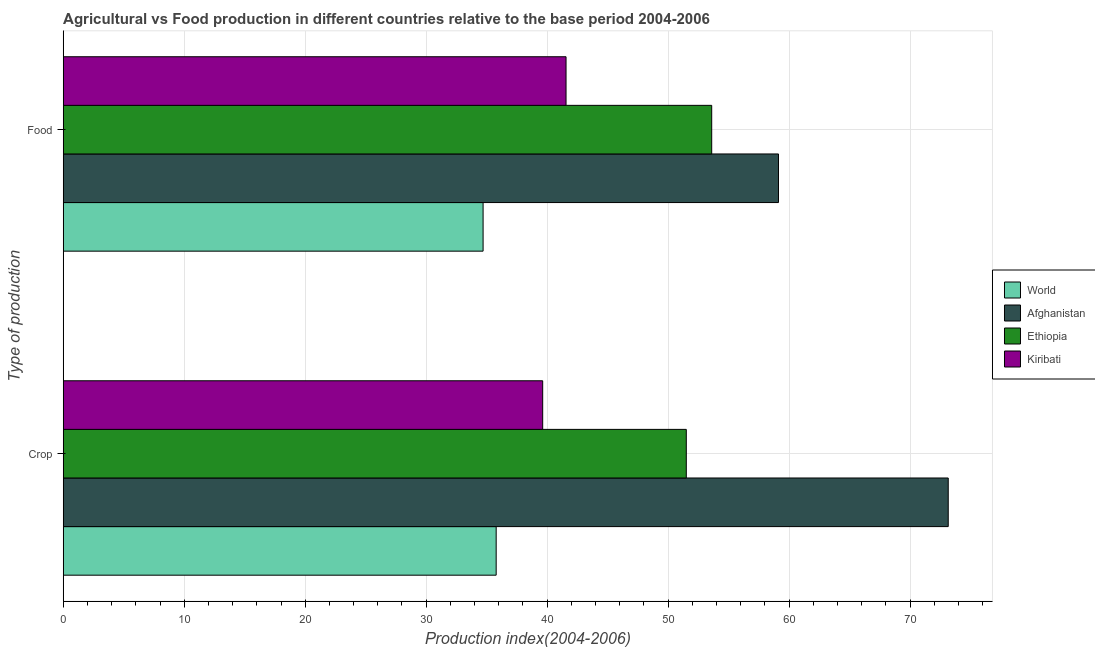How many different coloured bars are there?
Ensure brevity in your answer.  4. Are the number of bars per tick equal to the number of legend labels?
Your response must be concise. Yes. Are the number of bars on each tick of the Y-axis equal?
Your answer should be very brief. Yes. What is the label of the 1st group of bars from the top?
Offer a terse response. Food. What is the crop production index in Ethiopia?
Provide a short and direct response. 51.5. Across all countries, what is the maximum crop production index?
Your answer should be very brief. 73.15. Across all countries, what is the minimum crop production index?
Provide a succinct answer. 35.78. In which country was the food production index maximum?
Keep it short and to the point. Afghanistan. What is the total crop production index in the graph?
Your answer should be very brief. 200.06. What is the difference between the food production index in Afghanistan and that in Kiribati?
Your response must be concise. 17.56. What is the difference between the food production index in World and the crop production index in Kiribati?
Ensure brevity in your answer.  -4.93. What is the average crop production index per country?
Offer a terse response. 50.02. What is the difference between the crop production index and food production index in World?
Your answer should be compact. 1.08. In how many countries, is the food production index greater than 38 ?
Your response must be concise. 3. What is the ratio of the crop production index in Ethiopia to that in Kiribati?
Ensure brevity in your answer.  1.3. In how many countries, is the food production index greater than the average food production index taken over all countries?
Make the answer very short. 2. What does the 3rd bar from the top in Food represents?
Your response must be concise. Afghanistan. How many bars are there?
Your answer should be compact. 8. Does the graph contain any zero values?
Provide a succinct answer. No. Where does the legend appear in the graph?
Your response must be concise. Center right. How many legend labels are there?
Offer a terse response. 4. How are the legend labels stacked?
Give a very brief answer. Vertical. What is the title of the graph?
Provide a succinct answer. Agricultural vs Food production in different countries relative to the base period 2004-2006. Does "Canada" appear as one of the legend labels in the graph?
Offer a terse response. No. What is the label or title of the X-axis?
Provide a succinct answer. Production index(2004-2006). What is the label or title of the Y-axis?
Offer a very short reply. Type of production. What is the Production index(2004-2006) of World in Crop?
Ensure brevity in your answer.  35.78. What is the Production index(2004-2006) in Afghanistan in Crop?
Give a very brief answer. 73.15. What is the Production index(2004-2006) in Ethiopia in Crop?
Ensure brevity in your answer.  51.5. What is the Production index(2004-2006) in Kiribati in Crop?
Offer a very short reply. 39.63. What is the Production index(2004-2006) in World in Food?
Give a very brief answer. 34.7. What is the Production index(2004-2006) of Afghanistan in Food?
Ensure brevity in your answer.  59.12. What is the Production index(2004-2006) of Ethiopia in Food?
Ensure brevity in your answer.  53.6. What is the Production index(2004-2006) in Kiribati in Food?
Provide a succinct answer. 41.56. Across all Type of production, what is the maximum Production index(2004-2006) in World?
Offer a very short reply. 35.78. Across all Type of production, what is the maximum Production index(2004-2006) of Afghanistan?
Make the answer very short. 73.15. Across all Type of production, what is the maximum Production index(2004-2006) in Ethiopia?
Make the answer very short. 53.6. Across all Type of production, what is the maximum Production index(2004-2006) in Kiribati?
Provide a short and direct response. 41.56. Across all Type of production, what is the minimum Production index(2004-2006) in World?
Make the answer very short. 34.7. Across all Type of production, what is the minimum Production index(2004-2006) in Afghanistan?
Provide a succinct answer. 59.12. Across all Type of production, what is the minimum Production index(2004-2006) of Ethiopia?
Your answer should be compact. 51.5. Across all Type of production, what is the minimum Production index(2004-2006) of Kiribati?
Provide a succinct answer. 39.63. What is the total Production index(2004-2006) of World in the graph?
Provide a succinct answer. 70.49. What is the total Production index(2004-2006) in Afghanistan in the graph?
Offer a terse response. 132.27. What is the total Production index(2004-2006) of Ethiopia in the graph?
Provide a succinct answer. 105.1. What is the total Production index(2004-2006) in Kiribati in the graph?
Make the answer very short. 81.19. What is the difference between the Production index(2004-2006) in World in Crop and that in Food?
Give a very brief answer. 1.08. What is the difference between the Production index(2004-2006) in Afghanistan in Crop and that in Food?
Make the answer very short. 14.03. What is the difference between the Production index(2004-2006) of Kiribati in Crop and that in Food?
Provide a short and direct response. -1.93. What is the difference between the Production index(2004-2006) of World in Crop and the Production index(2004-2006) of Afghanistan in Food?
Give a very brief answer. -23.34. What is the difference between the Production index(2004-2006) of World in Crop and the Production index(2004-2006) of Ethiopia in Food?
Offer a terse response. -17.82. What is the difference between the Production index(2004-2006) of World in Crop and the Production index(2004-2006) of Kiribati in Food?
Keep it short and to the point. -5.78. What is the difference between the Production index(2004-2006) in Afghanistan in Crop and the Production index(2004-2006) in Ethiopia in Food?
Your answer should be very brief. 19.55. What is the difference between the Production index(2004-2006) of Afghanistan in Crop and the Production index(2004-2006) of Kiribati in Food?
Offer a very short reply. 31.59. What is the difference between the Production index(2004-2006) in Ethiopia in Crop and the Production index(2004-2006) in Kiribati in Food?
Keep it short and to the point. 9.94. What is the average Production index(2004-2006) in World per Type of production?
Keep it short and to the point. 35.24. What is the average Production index(2004-2006) of Afghanistan per Type of production?
Keep it short and to the point. 66.14. What is the average Production index(2004-2006) of Ethiopia per Type of production?
Offer a very short reply. 52.55. What is the average Production index(2004-2006) of Kiribati per Type of production?
Provide a succinct answer. 40.59. What is the difference between the Production index(2004-2006) in World and Production index(2004-2006) in Afghanistan in Crop?
Keep it short and to the point. -37.37. What is the difference between the Production index(2004-2006) in World and Production index(2004-2006) in Ethiopia in Crop?
Your response must be concise. -15.72. What is the difference between the Production index(2004-2006) in World and Production index(2004-2006) in Kiribati in Crop?
Give a very brief answer. -3.85. What is the difference between the Production index(2004-2006) of Afghanistan and Production index(2004-2006) of Ethiopia in Crop?
Your answer should be very brief. 21.65. What is the difference between the Production index(2004-2006) of Afghanistan and Production index(2004-2006) of Kiribati in Crop?
Offer a very short reply. 33.52. What is the difference between the Production index(2004-2006) of Ethiopia and Production index(2004-2006) of Kiribati in Crop?
Your response must be concise. 11.87. What is the difference between the Production index(2004-2006) of World and Production index(2004-2006) of Afghanistan in Food?
Offer a very short reply. -24.42. What is the difference between the Production index(2004-2006) of World and Production index(2004-2006) of Ethiopia in Food?
Provide a succinct answer. -18.9. What is the difference between the Production index(2004-2006) of World and Production index(2004-2006) of Kiribati in Food?
Your response must be concise. -6.86. What is the difference between the Production index(2004-2006) of Afghanistan and Production index(2004-2006) of Ethiopia in Food?
Provide a succinct answer. 5.52. What is the difference between the Production index(2004-2006) in Afghanistan and Production index(2004-2006) in Kiribati in Food?
Offer a very short reply. 17.56. What is the difference between the Production index(2004-2006) in Ethiopia and Production index(2004-2006) in Kiribati in Food?
Your answer should be very brief. 12.04. What is the ratio of the Production index(2004-2006) in World in Crop to that in Food?
Make the answer very short. 1.03. What is the ratio of the Production index(2004-2006) in Afghanistan in Crop to that in Food?
Offer a terse response. 1.24. What is the ratio of the Production index(2004-2006) in Ethiopia in Crop to that in Food?
Provide a short and direct response. 0.96. What is the ratio of the Production index(2004-2006) in Kiribati in Crop to that in Food?
Provide a succinct answer. 0.95. What is the difference between the highest and the second highest Production index(2004-2006) of World?
Give a very brief answer. 1.08. What is the difference between the highest and the second highest Production index(2004-2006) in Afghanistan?
Offer a terse response. 14.03. What is the difference between the highest and the second highest Production index(2004-2006) of Ethiopia?
Your response must be concise. 2.1. What is the difference between the highest and the second highest Production index(2004-2006) in Kiribati?
Your response must be concise. 1.93. What is the difference between the highest and the lowest Production index(2004-2006) of World?
Offer a very short reply. 1.08. What is the difference between the highest and the lowest Production index(2004-2006) of Afghanistan?
Make the answer very short. 14.03. What is the difference between the highest and the lowest Production index(2004-2006) of Kiribati?
Keep it short and to the point. 1.93. 